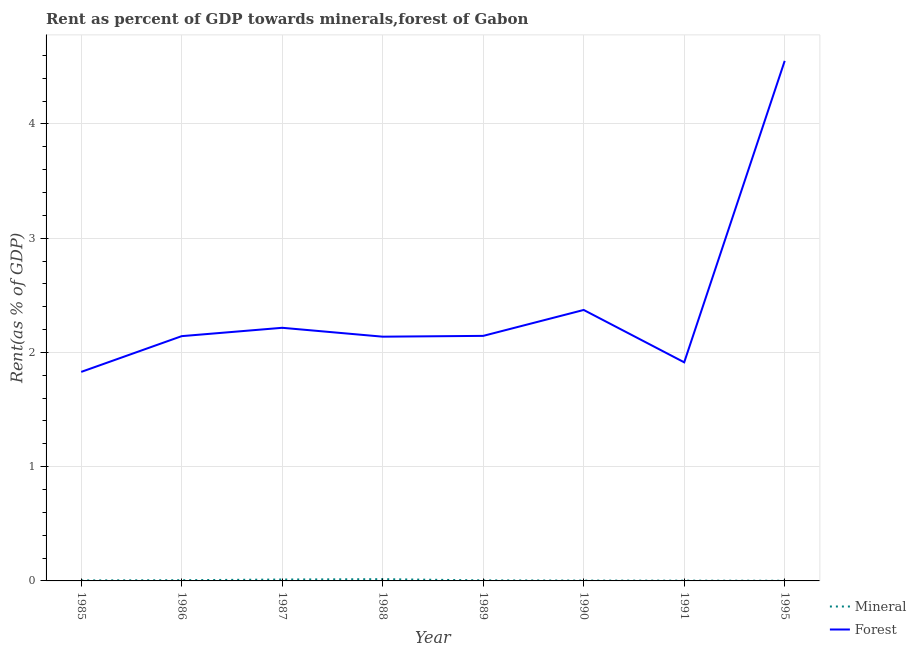How many different coloured lines are there?
Offer a terse response. 2. What is the forest rent in 1985?
Make the answer very short. 1.83. Across all years, what is the maximum mineral rent?
Your answer should be very brief. 0.02. Across all years, what is the minimum forest rent?
Keep it short and to the point. 1.83. In which year was the forest rent maximum?
Make the answer very short. 1995. In which year was the forest rent minimum?
Make the answer very short. 1985. What is the total forest rent in the graph?
Keep it short and to the point. 19.31. What is the difference between the forest rent in 1985 and that in 1995?
Offer a terse response. -2.72. What is the difference between the mineral rent in 1985 and the forest rent in 1990?
Keep it short and to the point. -2.37. What is the average forest rent per year?
Your answer should be very brief. 2.41. In the year 1987, what is the difference between the mineral rent and forest rent?
Make the answer very short. -2.2. In how many years, is the forest rent greater than 4.4 %?
Offer a very short reply. 1. What is the ratio of the forest rent in 1985 to that in 1990?
Offer a very short reply. 0.77. Is the difference between the mineral rent in 1987 and 1988 greater than the difference between the forest rent in 1987 and 1988?
Provide a short and direct response. No. What is the difference between the highest and the second highest forest rent?
Your response must be concise. 2.18. What is the difference between the highest and the lowest mineral rent?
Keep it short and to the point. 0.01. In how many years, is the mineral rent greater than the average mineral rent taken over all years?
Your answer should be compact. 2. Is the mineral rent strictly greater than the forest rent over the years?
Make the answer very short. No. Is the mineral rent strictly less than the forest rent over the years?
Your answer should be very brief. Yes. How many lines are there?
Your answer should be compact. 2. What is the difference between two consecutive major ticks on the Y-axis?
Give a very brief answer. 1. Are the values on the major ticks of Y-axis written in scientific E-notation?
Offer a terse response. No. Does the graph contain any zero values?
Offer a terse response. No. Does the graph contain grids?
Offer a terse response. Yes. How many legend labels are there?
Offer a terse response. 2. What is the title of the graph?
Your response must be concise. Rent as percent of GDP towards minerals,forest of Gabon. Does "Number of arrivals" appear as one of the legend labels in the graph?
Your answer should be compact. No. What is the label or title of the Y-axis?
Keep it short and to the point. Rent(as % of GDP). What is the Rent(as % of GDP) of Mineral in 1985?
Your answer should be compact. 0. What is the Rent(as % of GDP) of Forest in 1985?
Give a very brief answer. 1.83. What is the Rent(as % of GDP) of Mineral in 1986?
Your answer should be compact. 0.01. What is the Rent(as % of GDP) in Forest in 1986?
Offer a very short reply. 2.14. What is the Rent(as % of GDP) of Mineral in 1987?
Provide a short and direct response. 0.01. What is the Rent(as % of GDP) in Forest in 1987?
Offer a terse response. 2.22. What is the Rent(as % of GDP) in Mineral in 1988?
Make the answer very short. 0.02. What is the Rent(as % of GDP) in Forest in 1988?
Provide a succinct answer. 2.14. What is the Rent(as % of GDP) in Mineral in 1989?
Your answer should be compact. 0. What is the Rent(as % of GDP) in Forest in 1989?
Your response must be concise. 2.14. What is the Rent(as % of GDP) of Mineral in 1990?
Provide a succinct answer. 0. What is the Rent(as % of GDP) in Forest in 1990?
Provide a succinct answer. 2.37. What is the Rent(as % of GDP) in Mineral in 1991?
Your response must be concise. 0. What is the Rent(as % of GDP) of Forest in 1991?
Offer a terse response. 1.91. What is the Rent(as % of GDP) of Mineral in 1995?
Provide a succinct answer. 0. What is the Rent(as % of GDP) in Forest in 1995?
Ensure brevity in your answer.  4.55. Across all years, what is the maximum Rent(as % of GDP) in Mineral?
Offer a terse response. 0.02. Across all years, what is the maximum Rent(as % of GDP) of Forest?
Provide a short and direct response. 4.55. Across all years, what is the minimum Rent(as % of GDP) of Mineral?
Offer a very short reply. 0. Across all years, what is the minimum Rent(as % of GDP) of Forest?
Your answer should be compact. 1.83. What is the total Rent(as % of GDP) in Mineral in the graph?
Your response must be concise. 0.05. What is the total Rent(as % of GDP) of Forest in the graph?
Give a very brief answer. 19.31. What is the difference between the Rent(as % of GDP) of Mineral in 1985 and that in 1986?
Make the answer very short. -0. What is the difference between the Rent(as % of GDP) in Forest in 1985 and that in 1986?
Offer a very short reply. -0.31. What is the difference between the Rent(as % of GDP) of Mineral in 1985 and that in 1987?
Provide a short and direct response. -0.01. What is the difference between the Rent(as % of GDP) in Forest in 1985 and that in 1987?
Your answer should be very brief. -0.39. What is the difference between the Rent(as % of GDP) in Mineral in 1985 and that in 1988?
Keep it short and to the point. -0.01. What is the difference between the Rent(as % of GDP) in Forest in 1985 and that in 1988?
Your response must be concise. -0.31. What is the difference between the Rent(as % of GDP) of Mineral in 1985 and that in 1989?
Keep it short and to the point. -0. What is the difference between the Rent(as % of GDP) in Forest in 1985 and that in 1989?
Give a very brief answer. -0.32. What is the difference between the Rent(as % of GDP) in Mineral in 1985 and that in 1990?
Provide a short and direct response. 0. What is the difference between the Rent(as % of GDP) in Forest in 1985 and that in 1990?
Offer a terse response. -0.54. What is the difference between the Rent(as % of GDP) of Mineral in 1985 and that in 1991?
Ensure brevity in your answer.  0. What is the difference between the Rent(as % of GDP) of Forest in 1985 and that in 1991?
Provide a succinct answer. -0.08. What is the difference between the Rent(as % of GDP) in Mineral in 1985 and that in 1995?
Ensure brevity in your answer.  0. What is the difference between the Rent(as % of GDP) in Forest in 1985 and that in 1995?
Give a very brief answer. -2.72. What is the difference between the Rent(as % of GDP) of Mineral in 1986 and that in 1987?
Your answer should be very brief. -0.01. What is the difference between the Rent(as % of GDP) of Forest in 1986 and that in 1987?
Ensure brevity in your answer.  -0.07. What is the difference between the Rent(as % of GDP) in Mineral in 1986 and that in 1988?
Give a very brief answer. -0.01. What is the difference between the Rent(as % of GDP) in Forest in 1986 and that in 1988?
Provide a short and direct response. 0. What is the difference between the Rent(as % of GDP) in Mineral in 1986 and that in 1989?
Your response must be concise. 0. What is the difference between the Rent(as % of GDP) of Forest in 1986 and that in 1989?
Your answer should be compact. -0. What is the difference between the Rent(as % of GDP) of Mineral in 1986 and that in 1990?
Give a very brief answer. 0. What is the difference between the Rent(as % of GDP) in Forest in 1986 and that in 1990?
Give a very brief answer. -0.23. What is the difference between the Rent(as % of GDP) in Mineral in 1986 and that in 1991?
Make the answer very short. 0. What is the difference between the Rent(as % of GDP) in Forest in 1986 and that in 1991?
Make the answer very short. 0.23. What is the difference between the Rent(as % of GDP) in Mineral in 1986 and that in 1995?
Your answer should be compact. 0. What is the difference between the Rent(as % of GDP) of Forest in 1986 and that in 1995?
Provide a succinct answer. -2.41. What is the difference between the Rent(as % of GDP) of Mineral in 1987 and that in 1988?
Give a very brief answer. -0. What is the difference between the Rent(as % of GDP) of Forest in 1987 and that in 1988?
Make the answer very short. 0.08. What is the difference between the Rent(as % of GDP) of Mineral in 1987 and that in 1989?
Offer a terse response. 0.01. What is the difference between the Rent(as % of GDP) of Forest in 1987 and that in 1989?
Provide a short and direct response. 0.07. What is the difference between the Rent(as % of GDP) of Mineral in 1987 and that in 1990?
Make the answer very short. 0.01. What is the difference between the Rent(as % of GDP) in Forest in 1987 and that in 1990?
Provide a succinct answer. -0.16. What is the difference between the Rent(as % of GDP) of Mineral in 1987 and that in 1991?
Provide a succinct answer. 0.01. What is the difference between the Rent(as % of GDP) of Forest in 1987 and that in 1991?
Your answer should be compact. 0.3. What is the difference between the Rent(as % of GDP) of Mineral in 1987 and that in 1995?
Provide a succinct answer. 0.01. What is the difference between the Rent(as % of GDP) in Forest in 1987 and that in 1995?
Provide a short and direct response. -2.34. What is the difference between the Rent(as % of GDP) in Mineral in 1988 and that in 1989?
Your answer should be very brief. 0.01. What is the difference between the Rent(as % of GDP) of Forest in 1988 and that in 1989?
Offer a terse response. -0.01. What is the difference between the Rent(as % of GDP) in Mineral in 1988 and that in 1990?
Your response must be concise. 0.01. What is the difference between the Rent(as % of GDP) in Forest in 1988 and that in 1990?
Keep it short and to the point. -0.23. What is the difference between the Rent(as % of GDP) of Mineral in 1988 and that in 1991?
Offer a very short reply. 0.01. What is the difference between the Rent(as % of GDP) of Forest in 1988 and that in 1991?
Keep it short and to the point. 0.22. What is the difference between the Rent(as % of GDP) in Mineral in 1988 and that in 1995?
Your answer should be compact. 0.01. What is the difference between the Rent(as % of GDP) in Forest in 1988 and that in 1995?
Keep it short and to the point. -2.41. What is the difference between the Rent(as % of GDP) of Mineral in 1989 and that in 1990?
Offer a terse response. 0. What is the difference between the Rent(as % of GDP) in Forest in 1989 and that in 1990?
Provide a short and direct response. -0.23. What is the difference between the Rent(as % of GDP) of Mineral in 1989 and that in 1991?
Your answer should be very brief. 0. What is the difference between the Rent(as % of GDP) of Forest in 1989 and that in 1991?
Your answer should be compact. 0.23. What is the difference between the Rent(as % of GDP) in Mineral in 1989 and that in 1995?
Your answer should be compact. 0. What is the difference between the Rent(as % of GDP) of Forest in 1989 and that in 1995?
Your answer should be compact. -2.41. What is the difference between the Rent(as % of GDP) of Mineral in 1990 and that in 1991?
Make the answer very short. 0. What is the difference between the Rent(as % of GDP) of Forest in 1990 and that in 1991?
Your answer should be very brief. 0.46. What is the difference between the Rent(as % of GDP) of Mineral in 1990 and that in 1995?
Make the answer very short. 0. What is the difference between the Rent(as % of GDP) of Forest in 1990 and that in 1995?
Make the answer very short. -2.18. What is the difference between the Rent(as % of GDP) of Mineral in 1991 and that in 1995?
Ensure brevity in your answer.  0. What is the difference between the Rent(as % of GDP) in Forest in 1991 and that in 1995?
Offer a very short reply. -2.64. What is the difference between the Rent(as % of GDP) of Mineral in 1985 and the Rent(as % of GDP) of Forest in 1986?
Your response must be concise. -2.14. What is the difference between the Rent(as % of GDP) of Mineral in 1985 and the Rent(as % of GDP) of Forest in 1987?
Your response must be concise. -2.21. What is the difference between the Rent(as % of GDP) of Mineral in 1985 and the Rent(as % of GDP) of Forest in 1988?
Offer a terse response. -2.13. What is the difference between the Rent(as % of GDP) in Mineral in 1985 and the Rent(as % of GDP) in Forest in 1989?
Ensure brevity in your answer.  -2.14. What is the difference between the Rent(as % of GDP) of Mineral in 1985 and the Rent(as % of GDP) of Forest in 1990?
Make the answer very short. -2.37. What is the difference between the Rent(as % of GDP) in Mineral in 1985 and the Rent(as % of GDP) in Forest in 1991?
Keep it short and to the point. -1.91. What is the difference between the Rent(as % of GDP) in Mineral in 1985 and the Rent(as % of GDP) in Forest in 1995?
Offer a very short reply. -4.55. What is the difference between the Rent(as % of GDP) of Mineral in 1986 and the Rent(as % of GDP) of Forest in 1987?
Offer a terse response. -2.21. What is the difference between the Rent(as % of GDP) in Mineral in 1986 and the Rent(as % of GDP) in Forest in 1988?
Your answer should be very brief. -2.13. What is the difference between the Rent(as % of GDP) of Mineral in 1986 and the Rent(as % of GDP) of Forest in 1989?
Your answer should be compact. -2.14. What is the difference between the Rent(as % of GDP) of Mineral in 1986 and the Rent(as % of GDP) of Forest in 1990?
Provide a succinct answer. -2.37. What is the difference between the Rent(as % of GDP) of Mineral in 1986 and the Rent(as % of GDP) of Forest in 1991?
Offer a very short reply. -1.91. What is the difference between the Rent(as % of GDP) of Mineral in 1986 and the Rent(as % of GDP) of Forest in 1995?
Make the answer very short. -4.55. What is the difference between the Rent(as % of GDP) of Mineral in 1987 and the Rent(as % of GDP) of Forest in 1988?
Provide a short and direct response. -2.13. What is the difference between the Rent(as % of GDP) of Mineral in 1987 and the Rent(as % of GDP) of Forest in 1989?
Offer a terse response. -2.13. What is the difference between the Rent(as % of GDP) in Mineral in 1987 and the Rent(as % of GDP) in Forest in 1990?
Offer a very short reply. -2.36. What is the difference between the Rent(as % of GDP) of Mineral in 1987 and the Rent(as % of GDP) of Forest in 1991?
Your response must be concise. -1.9. What is the difference between the Rent(as % of GDP) in Mineral in 1987 and the Rent(as % of GDP) in Forest in 1995?
Provide a succinct answer. -4.54. What is the difference between the Rent(as % of GDP) of Mineral in 1988 and the Rent(as % of GDP) of Forest in 1989?
Your answer should be compact. -2.13. What is the difference between the Rent(as % of GDP) of Mineral in 1988 and the Rent(as % of GDP) of Forest in 1990?
Give a very brief answer. -2.36. What is the difference between the Rent(as % of GDP) of Mineral in 1988 and the Rent(as % of GDP) of Forest in 1991?
Give a very brief answer. -1.9. What is the difference between the Rent(as % of GDP) in Mineral in 1988 and the Rent(as % of GDP) in Forest in 1995?
Ensure brevity in your answer.  -4.54. What is the difference between the Rent(as % of GDP) in Mineral in 1989 and the Rent(as % of GDP) in Forest in 1990?
Offer a terse response. -2.37. What is the difference between the Rent(as % of GDP) in Mineral in 1989 and the Rent(as % of GDP) in Forest in 1991?
Provide a succinct answer. -1.91. What is the difference between the Rent(as % of GDP) in Mineral in 1989 and the Rent(as % of GDP) in Forest in 1995?
Provide a short and direct response. -4.55. What is the difference between the Rent(as % of GDP) of Mineral in 1990 and the Rent(as % of GDP) of Forest in 1991?
Offer a terse response. -1.91. What is the difference between the Rent(as % of GDP) in Mineral in 1990 and the Rent(as % of GDP) in Forest in 1995?
Offer a very short reply. -4.55. What is the difference between the Rent(as % of GDP) of Mineral in 1991 and the Rent(as % of GDP) of Forest in 1995?
Offer a very short reply. -4.55. What is the average Rent(as % of GDP) of Mineral per year?
Your answer should be very brief. 0.01. What is the average Rent(as % of GDP) in Forest per year?
Make the answer very short. 2.41. In the year 1985, what is the difference between the Rent(as % of GDP) in Mineral and Rent(as % of GDP) in Forest?
Your response must be concise. -1.83. In the year 1986, what is the difference between the Rent(as % of GDP) in Mineral and Rent(as % of GDP) in Forest?
Keep it short and to the point. -2.14. In the year 1987, what is the difference between the Rent(as % of GDP) of Mineral and Rent(as % of GDP) of Forest?
Ensure brevity in your answer.  -2.2. In the year 1988, what is the difference between the Rent(as % of GDP) of Mineral and Rent(as % of GDP) of Forest?
Give a very brief answer. -2.12. In the year 1989, what is the difference between the Rent(as % of GDP) in Mineral and Rent(as % of GDP) in Forest?
Give a very brief answer. -2.14. In the year 1990, what is the difference between the Rent(as % of GDP) of Mineral and Rent(as % of GDP) of Forest?
Make the answer very short. -2.37. In the year 1991, what is the difference between the Rent(as % of GDP) of Mineral and Rent(as % of GDP) of Forest?
Your answer should be compact. -1.91. In the year 1995, what is the difference between the Rent(as % of GDP) of Mineral and Rent(as % of GDP) of Forest?
Your response must be concise. -4.55. What is the ratio of the Rent(as % of GDP) of Mineral in 1985 to that in 1986?
Make the answer very short. 0.7. What is the ratio of the Rent(as % of GDP) in Forest in 1985 to that in 1986?
Ensure brevity in your answer.  0.85. What is the ratio of the Rent(as % of GDP) of Mineral in 1985 to that in 1987?
Your answer should be compact. 0.36. What is the ratio of the Rent(as % of GDP) in Forest in 1985 to that in 1987?
Offer a terse response. 0.83. What is the ratio of the Rent(as % of GDP) of Mineral in 1985 to that in 1988?
Give a very brief answer. 0.29. What is the ratio of the Rent(as % of GDP) of Forest in 1985 to that in 1988?
Make the answer very short. 0.86. What is the ratio of the Rent(as % of GDP) in Mineral in 1985 to that in 1989?
Make the answer very short. 0.9. What is the ratio of the Rent(as % of GDP) in Forest in 1985 to that in 1989?
Give a very brief answer. 0.85. What is the ratio of the Rent(as % of GDP) in Mineral in 1985 to that in 1990?
Provide a succinct answer. 1.47. What is the ratio of the Rent(as % of GDP) in Forest in 1985 to that in 1990?
Your response must be concise. 0.77. What is the ratio of the Rent(as % of GDP) of Mineral in 1985 to that in 1991?
Keep it short and to the point. 1.83. What is the ratio of the Rent(as % of GDP) of Forest in 1985 to that in 1991?
Give a very brief answer. 0.96. What is the ratio of the Rent(as % of GDP) of Mineral in 1985 to that in 1995?
Offer a terse response. 2.82. What is the ratio of the Rent(as % of GDP) in Forest in 1985 to that in 1995?
Provide a succinct answer. 0.4. What is the ratio of the Rent(as % of GDP) in Mineral in 1986 to that in 1987?
Provide a succinct answer. 0.51. What is the ratio of the Rent(as % of GDP) of Mineral in 1986 to that in 1988?
Provide a short and direct response. 0.41. What is the ratio of the Rent(as % of GDP) in Forest in 1986 to that in 1988?
Offer a terse response. 1. What is the ratio of the Rent(as % of GDP) in Mineral in 1986 to that in 1989?
Your answer should be very brief. 1.28. What is the ratio of the Rent(as % of GDP) of Forest in 1986 to that in 1989?
Keep it short and to the point. 1. What is the ratio of the Rent(as % of GDP) in Mineral in 1986 to that in 1990?
Make the answer very short. 2.1. What is the ratio of the Rent(as % of GDP) of Forest in 1986 to that in 1990?
Make the answer very short. 0.9. What is the ratio of the Rent(as % of GDP) of Mineral in 1986 to that in 1991?
Your response must be concise. 2.6. What is the ratio of the Rent(as % of GDP) in Forest in 1986 to that in 1991?
Offer a very short reply. 1.12. What is the ratio of the Rent(as % of GDP) in Mineral in 1986 to that in 1995?
Keep it short and to the point. 4.03. What is the ratio of the Rent(as % of GDP) of Forest in 1986 to that in 1995?
Give a very brief answer. 0.47. What is the ratio of the Rent(as % of GDP) in Mineral in 1987 to that in 1988?
Give a very brief answer. 0.8. What is the ratio of the Rent(as % of GDP) of Forest in 1987 to that in 1988?
Provide a succinct answer. 1.04. What is the ratio of the Rent(as % of GDP) in Mineral in 1987 to that in 1989?
Make the answer very short. 2.52. What is the ratio of the Rent(as % of GDP) of Forest in 1987 to that in 1989?
Provide a succinct answer. 1.03. What is the ratio of the Rent(as % of GDP) in Mineral in 1987 to that in 1990?
Offer a terse response. 4.13. What is the ratio of the Rent(as % of GDP) in Forest in 1987 to that in 1990?
Your answer should be compact. 0.93. What is the ratio of the Rent(as % of GDP) in Mineral in 1987 to that in 1991?
Make the answer very short. 5.12. What is the ratio of the Rent(as % of GDP) in Forest in 1987 to that in 1991?
Your response must be concise. 1.16. What is the ratio of the Rent(as % of GDP) in Mineral in 1987 to that in 1995?
Provide a succinct answer. 7.92. What is the ratio of the Rent(as % of GDP) in Forest in 1987 to that in 1995?
Make the answer very short. 0.49. What is the ratio of the Rent(as % of GDP) in Mineral in 1988 to that in 1989?
Offer a very short reply. 3.14. What is the ratio of the Rent(as % of GDP) in Forest in 1988 to that in 1989?
Your answer should be very brief. 1. What is the ratio of the Rent(as % of GDP) of Mineral in 1988 to that in 1990?
Offer a terse response. 5.15. What is the ratio of the Rent(as % of GDP) of Forest in 1988 to that in 1990?
Make the answer very short. 0.9. What is the ratio of the Rent(as % of GDP) in Mineral in 1988 to that in 1991?
Give a very brief answer. 6.39. What is the ratio of the Rent(as % of GDP) in Forest in 1988 to that in 1991?
Keep it short and to the point. 1.12. What is the ratio of the Rent(as % of GDP) in Mineral in 1988 to that in 1995?
Your answer should be very brief. 9.89. What is the ratio of the Rent(as % of GDP) of Forest in 1988 to that in 1995?
Offer a very short reply. 0.47. What is the ratio of the Rent(as % of GDP) in Mineral in 1989 to that in 1990?
Give a very brief answer. 1.64. What is the ratio of the Rent(as % of GDP) in Forest in 1989 to that in 1990?
Offer a terse response. 0.9. What is the ratio of the Rent(as % of GDP) in Mineral in 1989 to that in 1991?
Ensure brevity in your answer.  2.03. What is the ratio of the Rent(as % of GDP) of Forest in 1989 to that in 1991?
Make the answer very short. 1.12. What is the ratio of the Rent(as % of GDP) in Mineral in 1989 to that in 1995?
Give a very brief answer. 3.15. What is the ratio of the Rent(as % of GDP) in Forest in 1989 to that in 1995?
Your answer should be compact. 0.47. What is the ratio of the Rent(as % of GDP) in Mineral in 1990 to that in 1991?
Provide a succinct answer. 1.24. What is the ratio of the Rent(as % of GDP) of Forest in 1990 to that in 1991?
Ensure brevity in your answer.  1.24. What is the ratio of the Rent(as % of GDP) in Mineral in 1990 to that in 1995?
Make the answer very short. 1.92. What is the ratio of the Rent(as % of GDP) in Forest in 1990 to that in 1995?
Offer a terse response. 0.52. What is the ratio of the Rent(as % of GDP) in Mineral in 1991 to that in 1995?
Provide a succinct answer. 1.55. What is the ratio of the Rent(as % of GDP) of Forest in 1991 to that in 1995?
Offer a very short reply. 0.42. What is the difference between the highest and the second highest Rent(as % of GDP) in Mineral?
Make the answer very short. 0. What is the difference between the highest and the second highest Rent(as % of GDP) in Forest?
Make the answer very short. 2.18. What is the difference between the highest and the lowest Rent(as % of GDP) of Mineral?
Provide a succinct answer. 0.01. What is the difference between the highest and the lowest Rent(as % of GDP) in Forest?
Your response must be concise. 2.72. 